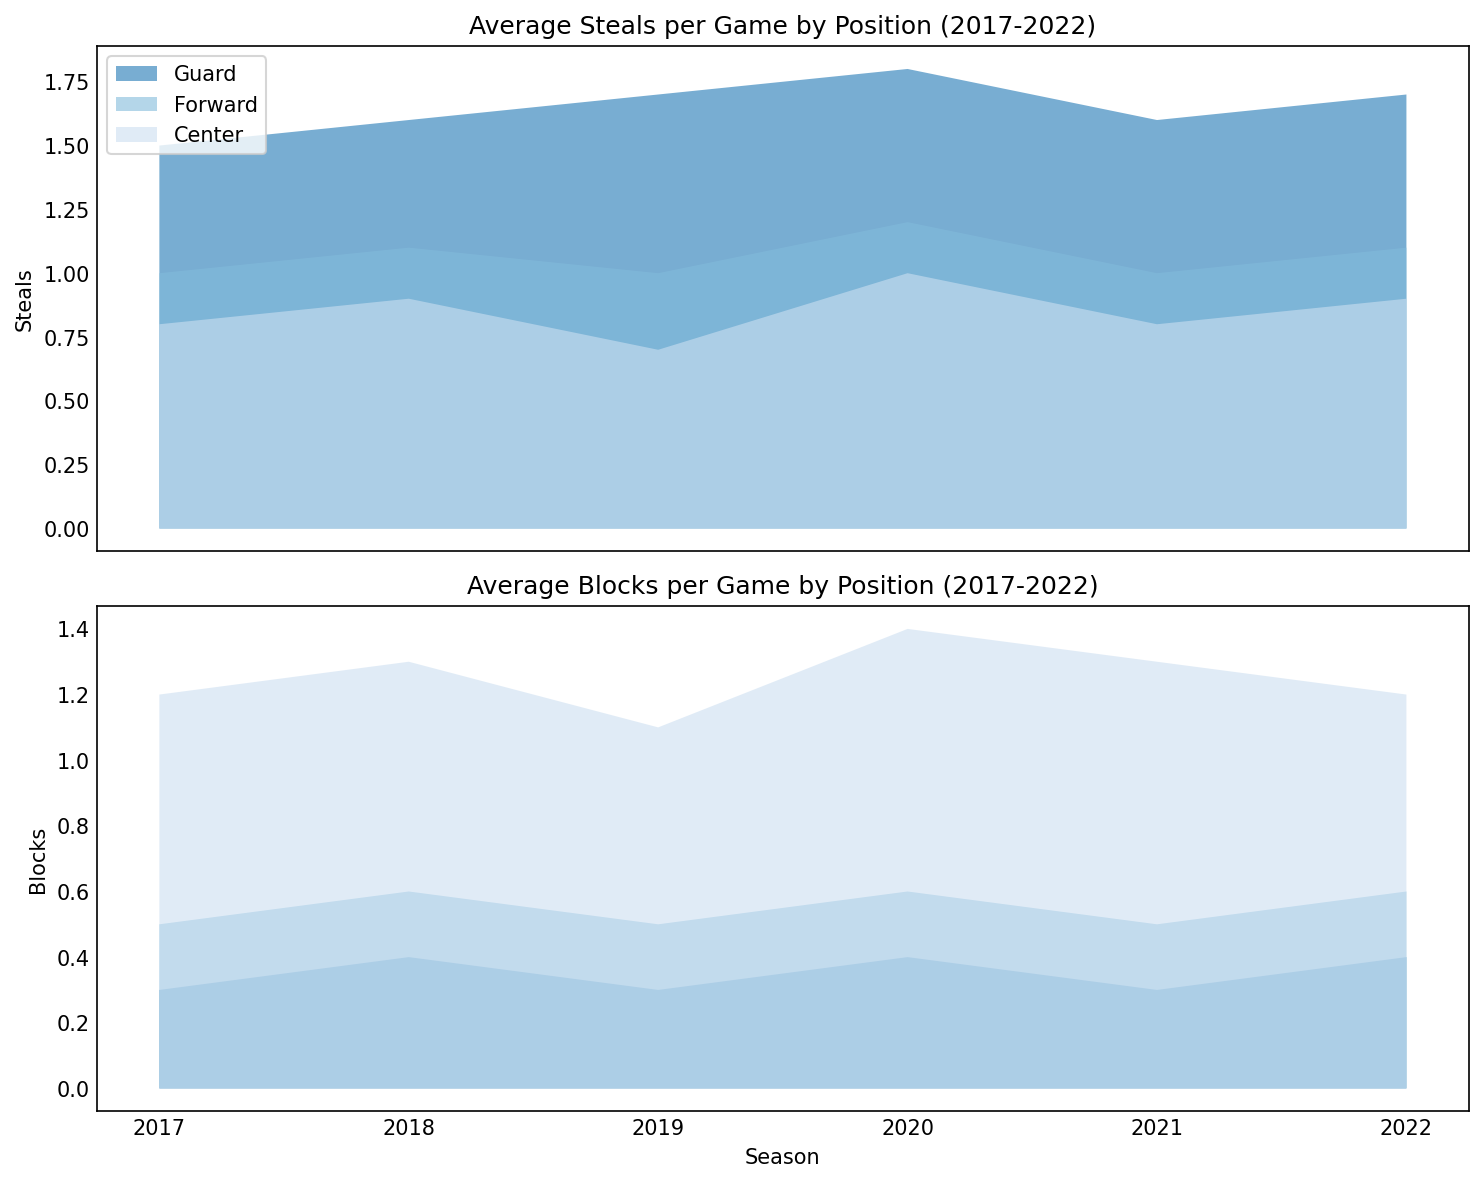What's the trend in average steals per game for guards from 2017 to 2022? Look at the data for guard steals over the seasons and identify if it increases, decreases, or remains constant. The plot shows a gradual increase in steals from 1.5 in 2017 to 1.7 in 2022, with some variations.
Answer: Gradual increase Which position consistently has the highest average blocks per game from 2017 to 2022? Observe the area chart for blocks and compare the heights of the filled areas for each position across seasons. The area representing centers is consistently higher than those of guards and forwards, indicating the highest blocks.
Answer: Center How much did the average steals per game for guards increase from 2017 to 2022? Determine the steals value for guards in 2017 (1.5) and 2022 (1.7), then calculate the difference: 1.7 - 1.5 = 0.2.
Answer: 0.2 Did the average blocks per game for forwards change from 2017 to 2022? Examine the blocks data for forwards at the start (0.5 in 2017) and end (0.6 in 2022) of the period. There is an increase of 0.1 blocks per game.
Answer: Yes, it increased by 0.1 In which season did guards achieve the peak average steals per game according to the chart? Identify the highest point in the steals area for guards. The peak is at 1.8 steals in the 2020 season.
Answer: 2020 Calculate the average blocks per game for centers over the seasons shown. Sum the blocks for centers across all seasons: 1.2 + 1.3 + 1.1 + 1.4 + 1.3 + 1.2 = 7.5. Then, divide by the number of seasons (6): 7.5 / 6 = 1.25.
Answer: 1.25 Compare the trends of steals for guards and forwards from 2017 to 2022. Observe the slopes of the areas for guards and forwards. Guards show a consistent upward trend overall, whereas forwards show a smaller increase, remaining around the 1.0 - 1.2 range.
Answer: Guards increased more Which position showed the most variability in blocks per game across seasons? Check the fluctuating heights of the filled areas in the blocks chart. The guards' blocks remain almost flat, forwards have slight variation, while centers fluctuate significantly.
Answer: Center Between which two consecutive seasons did the average blocks per game for centers decrease? Analyze year-to-year changes in the blocks area for centers. There was a drop from 2018 (1.3) to 2019 (1.1).
Answer: 2018 and 2019 In the year 2018, how did the average steals per game for guards compare to forwards? Find the values for 2018: guards have 1.6 and forwards have 1.1. Guards have more steals on average than forwards.
Answer: Guards > Forwards 